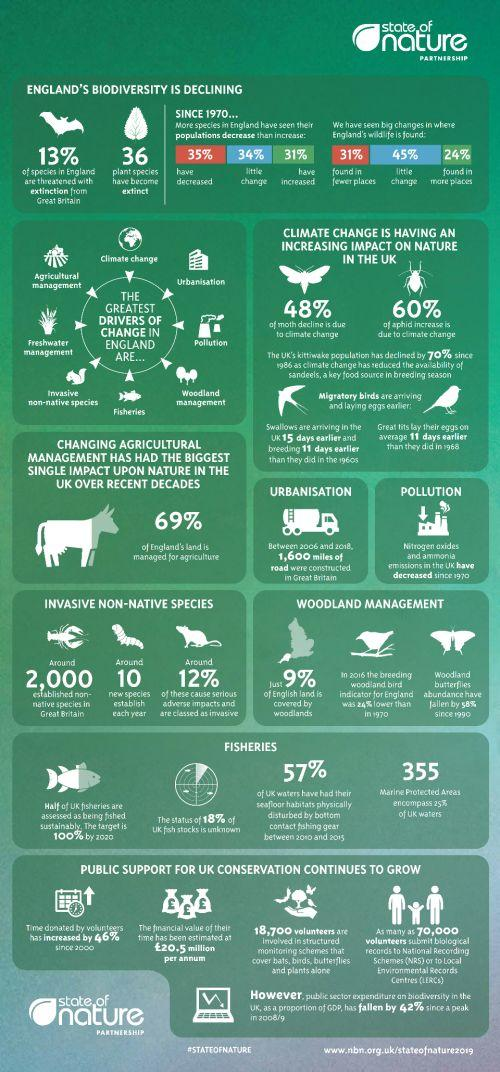Indicate a few pertinent items in this graphic. Approximately 50% of fishing practices are currently conducted in a sustainable manner. There are 355 marine protected areas in the UK that cover approximately 25% of the nation's waters. According to estimates, 36 plant species have become extinct. Sixty-nine percent of land is currently being used for agriculture. According to a recent survey, 34% of species have experienced relatively little change in their population since 1970. 